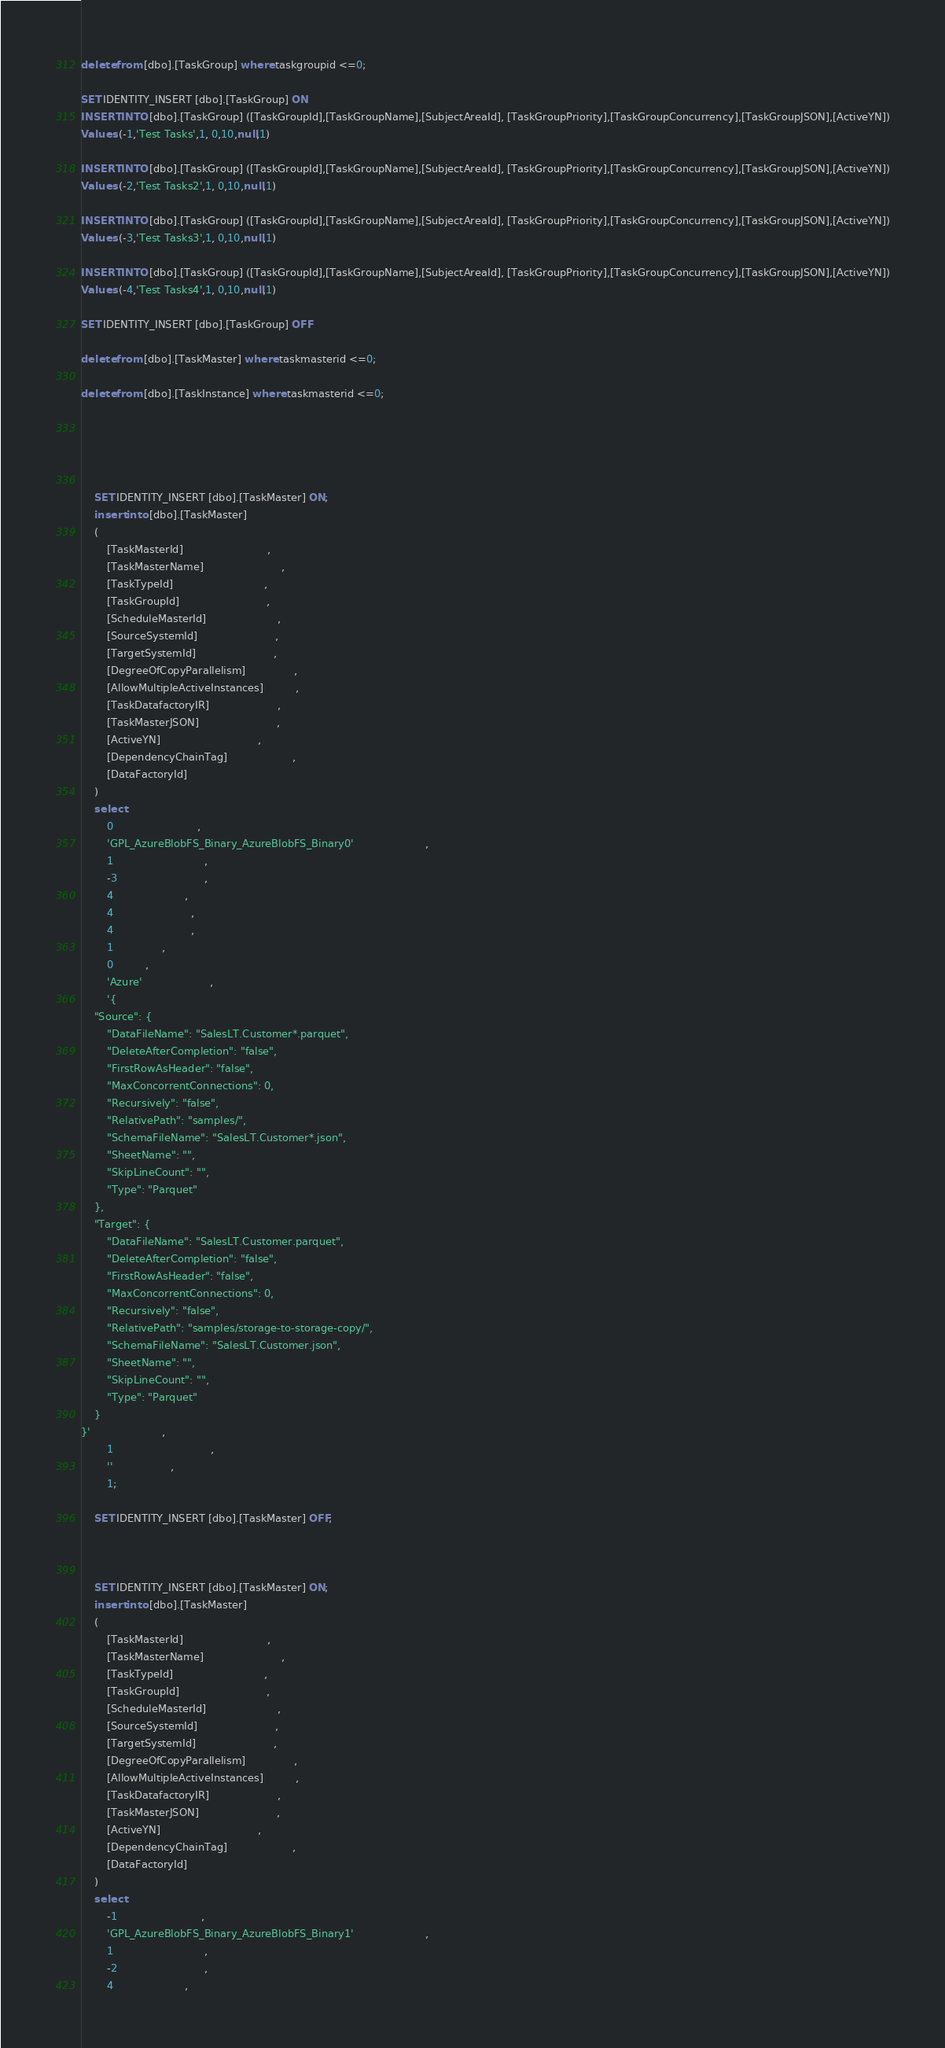Convert code to text. <code><loc_0><loc_0><loc_500><loc_500><_SQL_>delete from [dbo].[TaskGroup] where taskgroupid <=0;            
            
SET IDENTITY_INSERT [dbo].[TaskGroup] ON
INSERT INTO [dbo].[TaskGroup] ([TaskGroupId],[TaskGroupName],[SubjectAreaId], [TaskGroupPriority],[TaskGroupConcurrency],[TaskGroupJSON],[ActiveYN])
Values (-1,'Test Tasks',1, 0,10,null,1)

INSERT INTO [dbo].[TaskGroup] ([TaskGroupId],[TaskGroupName],[SubjectAreaId], [TaskGroupPriority],[TaskGroupConcurrency],[TaskGroupJSON],[ActiveYN])
Values (-2,'Test Tasks2',1, 0,10,null,1)

INSERT INTO [dbo].[TaskGroup] ([TaskGroupId],[TaskGroupName],[SubjectAreaId], [TaskGroupPriority],[TaskGroupConcurrency],[TaskGroupJSON],[ActiveYN])
Values (-3,'Test Tasks3',1, 0,10,null,1)

INSERT INTO [dbo].[TaskGroup] ([TaskGroupId],[TaskGroupName],[SubjectAreaId], [TaskGroupPriority],[TaskGroupConcurrency],[TaskGroupJSON],[ActiveYN])
Values (-4,'Test Tasks4',1, 0,10,null,1)

SET IDENTITY_INSERT [dbo].[TaskGroup] OFF

delete from [dbo].[TaskMaster] where taskmasterid <=0;

delete from [dbo].[TaskInstance] where taskmasterid <=0;




                                        
    SET IDENTITY_INSERT [dbo].[TaskMaster] ON;
    insert into [dbo].[TaskMaster]
    (
        [TaskMasterId]                          ,
        [TaskMasterName]                        ,
        [TaskTypeId]                            ,
        [TaskGroupId]                           ,
        [ScheduleMasterId]                      ,
        [SourceSystemId]                        ,
        [TargetSystemId]                        ,
        [DegreeOfCopyParallelism]               ,
        [AllowMultipleActiveInstances]          ,
        [TaskDatafactoryIR]                     ,
        [TaskMasterJSON]                        ,
        [ActiveYN]                              ,
        [DependencyChainTag]                    ,
        [DataFactoryId]                         
    )
    select 
        0                          ,
        'GPL_AzureBlobFS_Binary_AzureBlobFS_Binary0'                      ,
        1                            ,
        -3                           ,
        4                      ,
        4                        ,
        4                        ,
        1               ,
        0          ,
        'Azure'                     ,
        '{
    "Source": {
        "DataFileName": "SalesLT.Customer*.parquet",
        "DeleteAfterCompletion": "false",
        "FirstRowAsHeader": "false",
        "MaxConcorrentConnections": 0,
        "Recursively": "false",
        "RelativePath": "samples/",
        "SchemaFileName": "SalesLT.Customer*.json",
        "SheetName": "",
        "SkipLineCount": "",
        "Type": "Parquet"
    },
    "Target": {
        "DataFileName": "SalesLT.Customer.parquet",
        "DeleteAfterCompletion": "false",
        "FirstRowAsHeader": "false",
        "MaxConcorrentConnections": 0,
        "Recursively": "false",
        "RelativePath": "samples/storage-to-storage-copy/",
        "SchemaFileName": "SalesLT.Customer.json",
        "SheetName": "",
        "SkipLineCount": "",
        "Type": "Parquet"
    }
}'                      ,
        1                              ,
        ''                  ,
        1;  
    
    SET IDENTITY_INSERT [dbo].[TaskMaster] OFF;        
    
    
                                        
    SET IDENTITY_INSERT [dbo].[TaskMaster] ON;
    insert into [dbo].[TaskMaster]
    (
        [TaskMasterId]                          ,
        [TaskMasterName]                        ,
        [TaskTypeId]                            ,
        [TaskGroupId]                           ,
        [ScheduleMasterId]                      ,
        [SourceSystemId]                        ,
        [TargetSystemId]                        ,
        [DegreeOfCopyParallelism]               ,
        [AllowMultipleActiveInstances]          ,
        [TaskDatafactoryIR]                     ,
        [TaskMasterJSON]                        ,
        [ActiveYN]                              ,
        [DependencyChainTag]                    ,
        [DataFactoryId]                         
    )
    select 
        -1                          ,
        'GPL_AzureBlobFS_Binary_AzureBlobFS_Binary1'                      ,
        1                            ,
        -2                           ,
        4                      ,</code> 